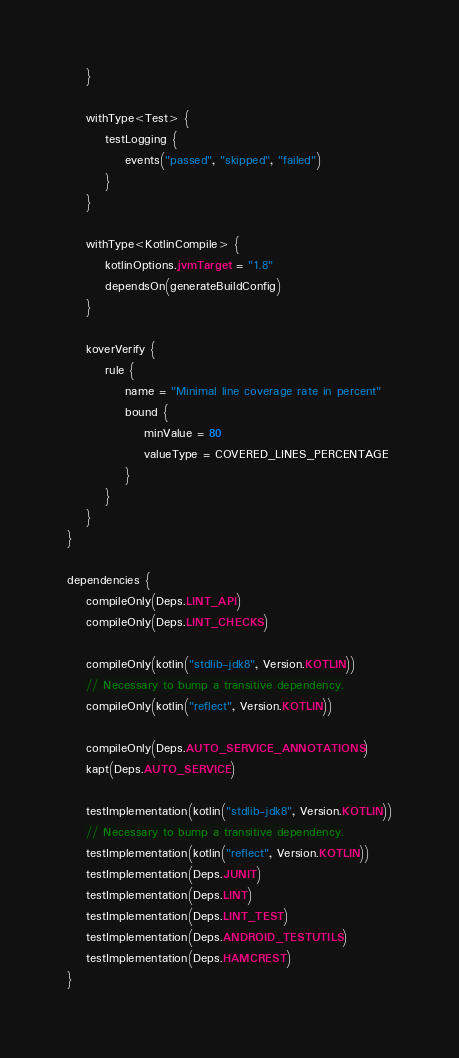<code> <loc_0><loc_0><loc_500><loc_500><_Kotlin_>    }

    withType<Test> {
        testLogging {
            events("passed", "skipped", "failed")
        }
    }

    withType<KotlinCompile> {
        kotlinOptions.jvmTarget = "1.8"
        dependsOn(generateBuildConfig)
    }

    koverVerify {
        rule {
            name = "Minimal line coverage rate in percent"
            bound {
                minValue = 80
                valueType = COVERED_LINES_PERCENTAGE
            }
        }
    }
}

dependencies {
    compileOnly(Deps.LINT_API)
    compileOnly(Deps.LINT_CHECKS)

    compileOnly(kotlin("stdlib-jdk8", Version.KOTLIN))
    // Necessary to bump a transitive dependency.
    compileOnly(kotlin("reflect", Version.KOTLIN))

    compileOnly(Deps.AUTO_SERVICE_ANNOTATIONS)
    kapt(Deps.AUTO_SERVICE)

    testImplementation(kotlin("stdlib-jdk8", Version.KOTLIN))
    // Necessary to bump a transitive dependency.
    testImplementation(kotlin("reflect", Version.KOTLIN))
    testImplementation(Deps.JUNIT)
    testImplementation(Deps.LINT)
    testImplementation(Deps.LINT_TEST)
    testImplementation(Deps.ANDROID_TESTUTILS)
    testImplementation(Deps.HAMCREST)
}
</code> 